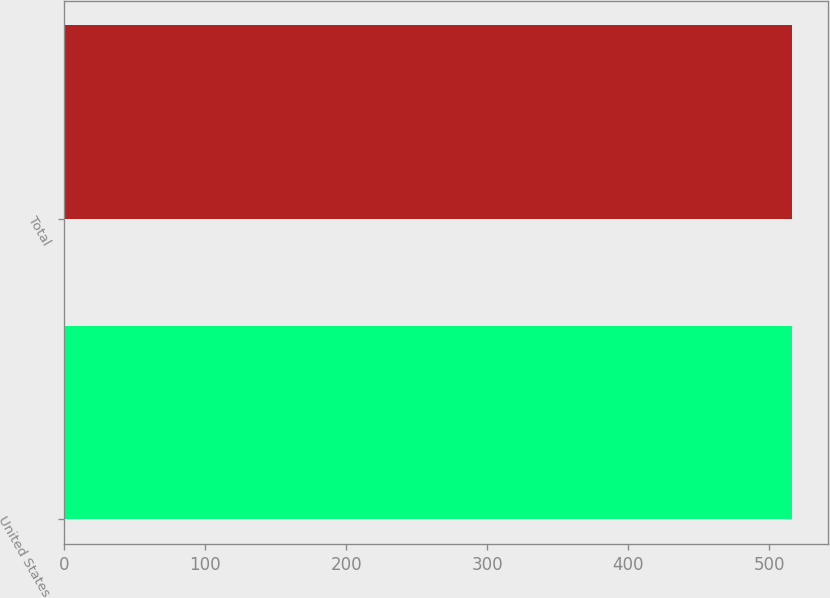Convert chart. <chart><loc_0><loc_0><loc_500><loc_500><bar_chart><fcel>United States<fcel>Total<nl><fcel>516<fcel>516.1<nl></chart> 